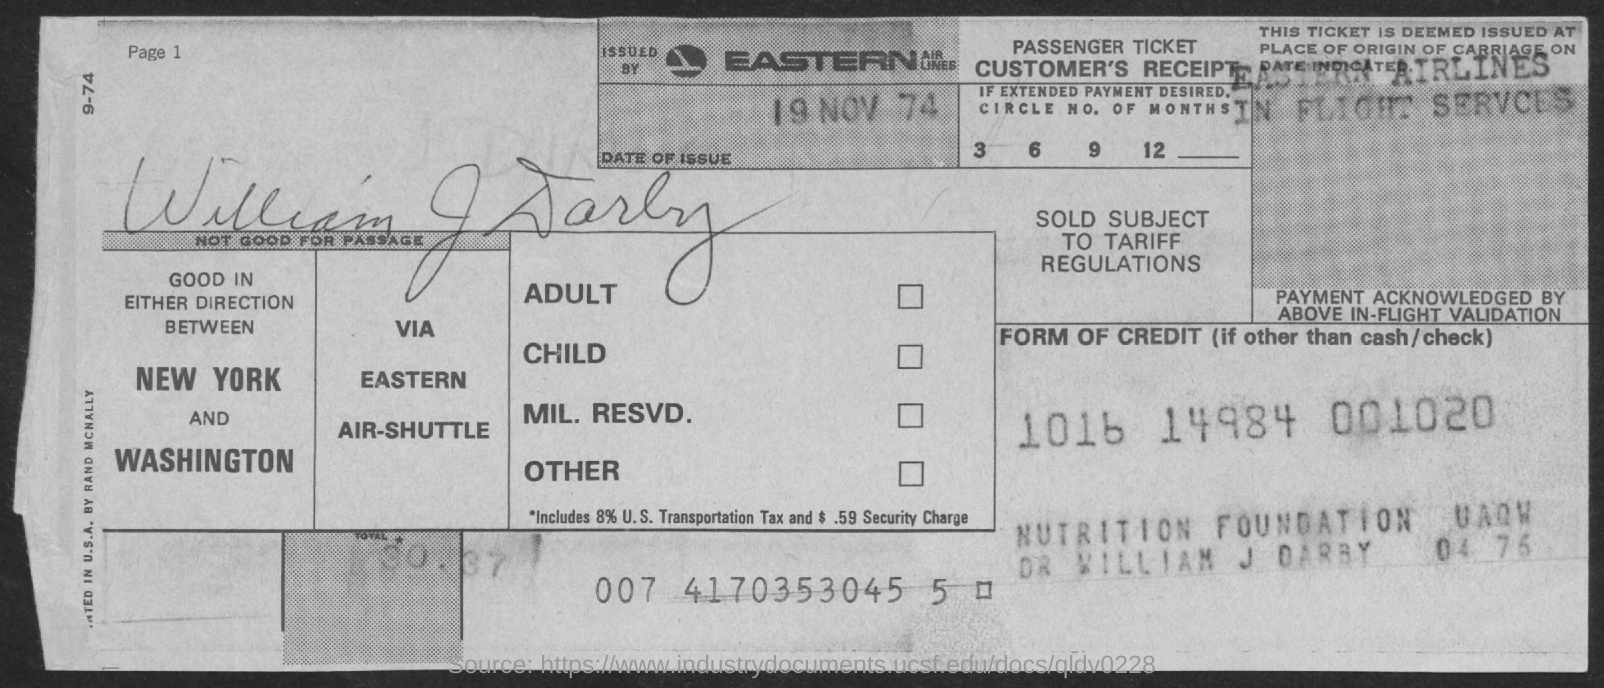What is the name of the person given in the receipt?
Keep it short and to the point. WILLIAM J DARBY. What is the date of issue given in the receipt?
Your response must be concise. 19 NOV 74. 